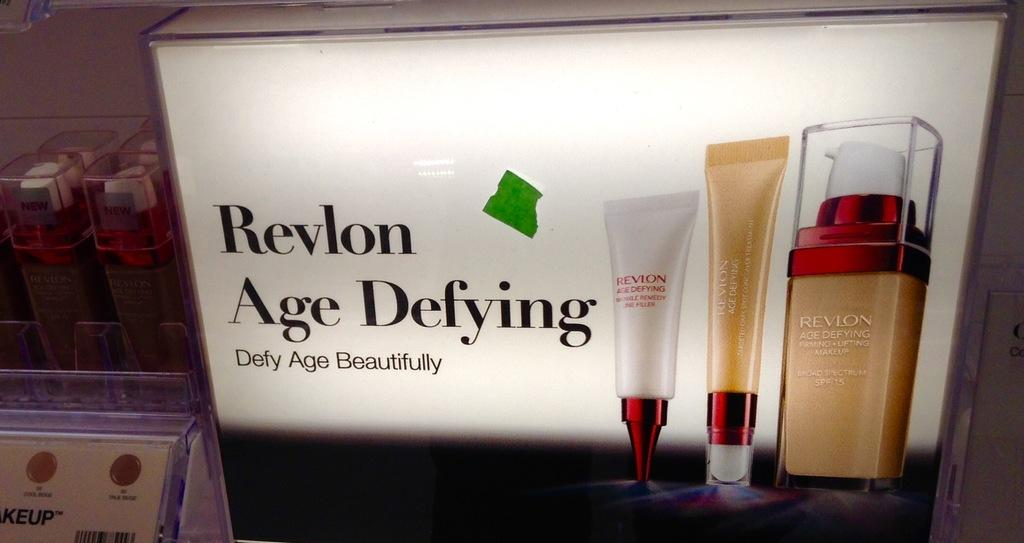<image>
Describe the image concisely. a sign in a store that says 'revlon age defying defy age beautifully' 